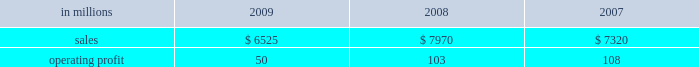Higher in the first half of the year , but declined dur- ing the second half of the year reflecting the pass- through to customers of lower resin input costs .
However , average margins benefitted from a more favorable mix of products sold .
Raw material costs were lower , primarily for resins .
Freight costs were also favorable , while operating costs increased .
Shorewood sales volumes in 2009 declined from 2008 levels reflecting weaker demand in the home entertainment segment and a decrease in tobacco segment orders as customers have shifted pro- duction outside of the united states , partially offset by higher shipments in the consumer products segment .
Average sales margins improved reflecting a more favorable mix of products sold .
Raw material costs were higher , but were partially offset by lower freight costs .
Operating costs were favorable , reflect- ing benefits from business reorganization and cost reduction actions taken in 2008 and 2009 .
Charges to restructure operations totaled $ 7 million in 2009 and $ 30 million in 2008 .
Entering 2010 , coated paperboard sales volumes are expected to increase , while average sales price real- izations should be comparable to 2009 fourth-quarter levels .
Raw material costs are expected to be sig- nificantly higher for wood , energy and chemicals , but planned maintenance downtime costs will decrease .
Foodservice sales volumes are expected to remain about flat , but average sales price realizations should improve slightly .
Input costs for resins should be higher , but will be partially offset by lower costs for bleached board .
Shorewood sales volumes are expected to decline reflecting seasonal decreases in home entertainment segment shipments .
Operating costs are expected to be favorable reflecting the benefits of business reorganization efforts .
European consumer packaging net sales in 2009 were $ 315 million compared with $ 300 million in 2008 and $ 280 million in 2007 .
Operating earnings in 2009 of $ 66 million increased from $ 22 million in 2008 and $ 30 million in 2007 .
Sales volumes in 2009 were higher than in 2008 reflecting increased ship- ments to export markets .
Average sales margins declined due to increased shipments to lower- margin export markets and lower average sales prices in western europe .
Entering 2010 , sales volumes for the first quarter are expected to remain strong .
Average margins should improve reflecting increased sales price realizations and a more favorable geographic mix of products sold .
Input costs are expected to be higher due to increased wood prices in poland and annual energy tariff increases in russia .
Asian consumer packaging net sales were $ 545 million in 2009 compared with $ 390 million in 2008 and $ 330 million in 2007 .
Operating earnings in 2009 were $ 24 million compared with a loss of $ 13 million in 2008 and earnings of $ 12 million in 2007 .
The improved operating earnings in 2009 reflect increased sales volumes , higher average sales mar- gins and lower input costs , primarily for chemicals .
The loss in 2008 was primarily due to a $ 12 million charge to revalue pulp inventories at our shandong international paper and sun coated paperboard co. , ltd .
Joint venture and start-up costs associated with the joint venture 2019s new folding box board paper machine .
Distribution xpedx , our distribution business , markets a diverse array of products and supply chain services to cus- tomers in many business segments .
Customer demand is generally sensitive to changes in general economic conditions , although the commercial printing segment is also dependent on consumer advertising and promotional spending .
Distribution 2019s margins are relatively stable across an economic cycle .
Providing customers with the best choice and value in both products and supply chain services is a key competitive factor .
Additionally , efficient customer service , cost-effective logistics and focused working capital management are key factors in this segment 2019s profitability .
Distribution in millions 2009 2008 2007 .
Distribution 2019s 2009 annual sales decreased 18% ( 18 % ) from 2008 and 11% ( 11 % ) from 2007 while operating profits in 2009 decreased 51% ( 51 % ) compared with 2008 and 54% ( 54 % ) compared with 2007 .
Annual sales of printing papers and graphic arts supplies and equipment totaled $ 4.1 billion in 2009 compared with $ 5.2 billion in 2008 and $ 4.7 billion in 2007 , reflecting weak economic conditions in 2009 .
Trade margins as a percent of sales for printing papers increased from 2008 but decreased from 2007 due to a higher mix of lower margin direct ship- ments from manufacturers .
Revenue from packaging products was $ 1.3 billion in 2009 compared with $ 1.7 billion in 2008 and $ 1.5 billion in 2007 .
Trade margins as a percent of sales for packaging products were higher than in the past two years reflecting an improved product and service mix .
Facility supplies annual revenue was $ 1.1 billion in 2009 , essentially .
What is the highest value of operating profit during this period? 
Rationale: it is the maximum value .
Computations: table_max(operating profit, none)
Answer: 108.0. 